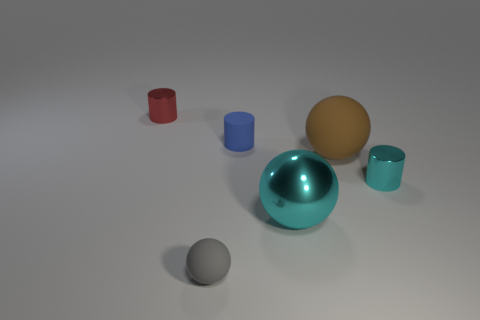If this assortment of objects were part of a product design, what might the purpose of these objects be? This collection of objects could be a designer's conceptual set for a minimalistic home decor line. The various shapes and sizes suggest they might serve as decorative elements with the additional functionality of containers or vases, embracing both aesthetic and utilitarian design principles. 